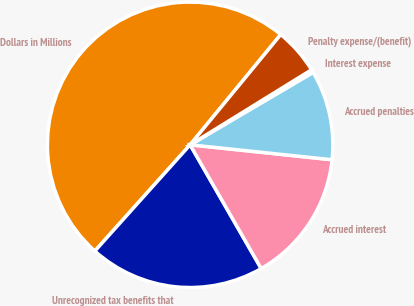<chart> <loc_0><loc_0><loc_500><loc_500><pie_chart><fcel>Dollars in Millions<fcel>Unrecognized tax benefits that<fcel>Accrued interest<fcel>Accrued penalties<fcel>Interest expense<fcel>Penalty expense/(benefit)<nl><fcel>49.31%<fcel>19.93%<fcel>15.03%<fcel>10.14%<fcel>0.34%<fcel>5.24%<nl></chart> 